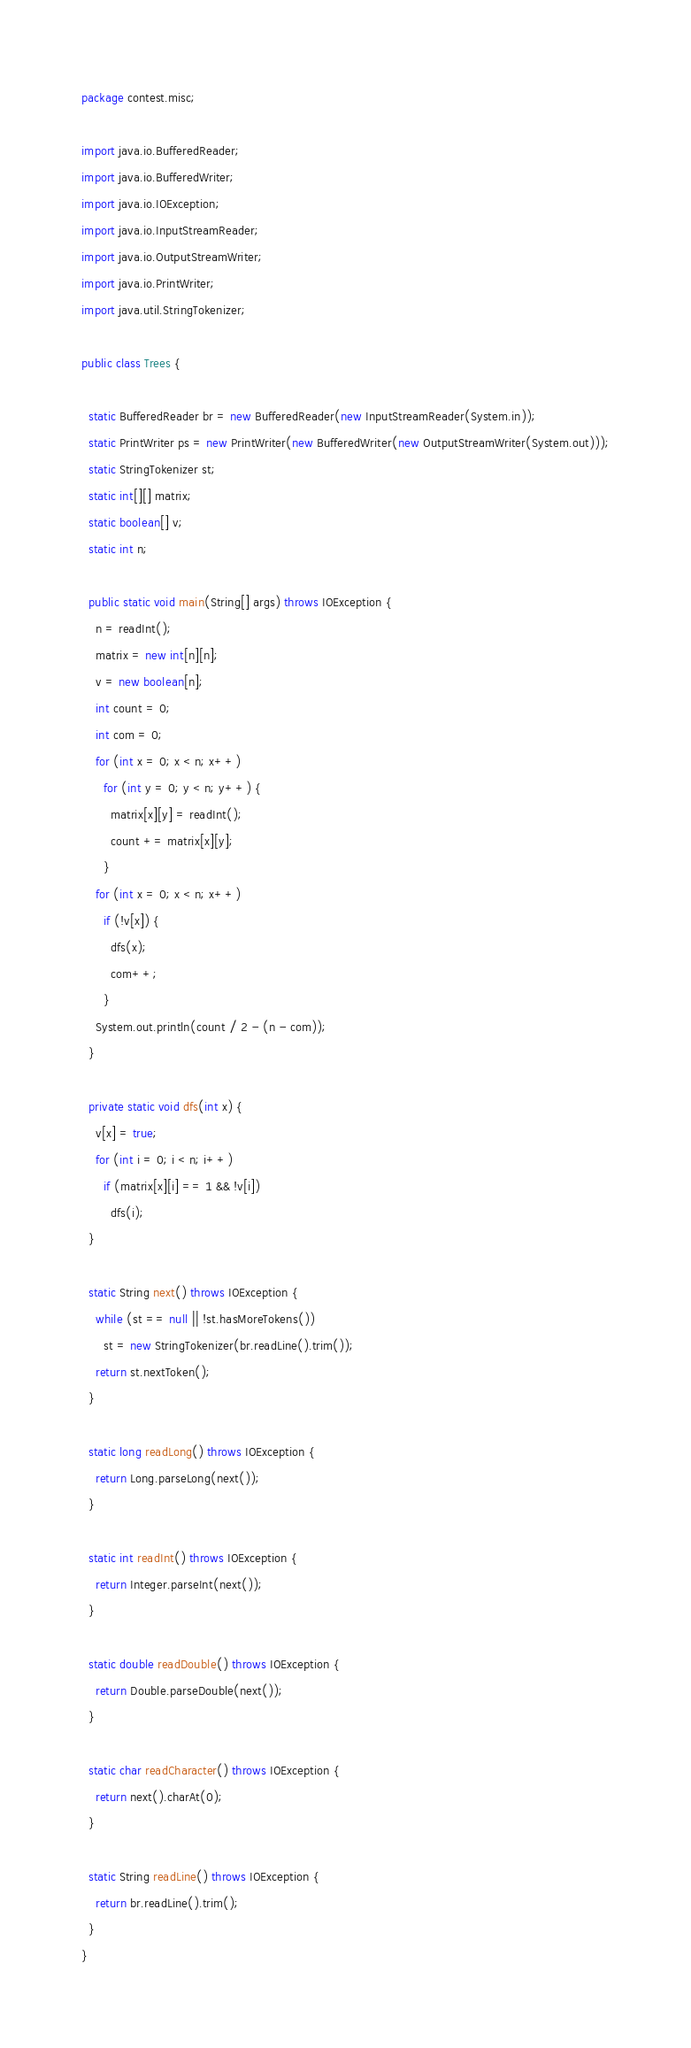Convert code to text. <code><loc_0><loc_0><loc_500><loc_500><_Java_>package contest.misc;

import java.io.BufferedReader;
import java.io.BufferedWriter;
import java.io.IOException;
import java.io.InputStreamReader;
import java.io.OutputStreamWriter;
import java.io.PrintWriter;
import java.util.StringTokenizer;

public class Trees {

  static BufferedReader br = new BufferedReader(new InputStreamReader(System.in));
  static PrintWriter ps = new PrintWriter(new BufferedWriter(new OutputStreamWriter(System.out)));
  static StringTokenizer st;
  static int[][] matrix;
  static boolean[] v;
  static int n;

  public static void main(String[] args) throws IOException {
    n = readInt();
    matrix = new int[n][n];
    v = new boolean[n];
    int count = 0;
    int com = 0;
    for (int x = 0; x < n; x++)
      for (int y = 0; y < n; y++) {
        matrix[x][y] = readInt();
        count += matrix[x][y];
      }
    for (int x = 0; x < n; x++)
      if (!v[x]) {
        dfs(x);
        com++;
      }
    System.out.println(count / 2 - (n - com));
  }

  private static void dfs(int x) {
    v[x] = true;
    for (int i = 0; i < n; i++)
      if (matrix[x][i] == 1 && !v[i])
        dfs(i);
  }

  static String next() throws IOException {
    while (st == null || !st.hasMoreTokens())
      st = new StringTokenizer(br.readLine().trim());
    return st.nextToken();
  }

  static long readLong() throws IOException {
    return Long.parseLong(next());
  }

  static int readInt() throws IOException {
    return Integer.parseInt(next());
  }

  static double readDouble() throws IOException {
    return Double.parseDouble(next());
  }

  static char readCharacter() throws IOException {
    return next().charAt(0);
  }

  static String readLine() throws IOException {
    return br.readLine().trim();
  }
}
</code> 